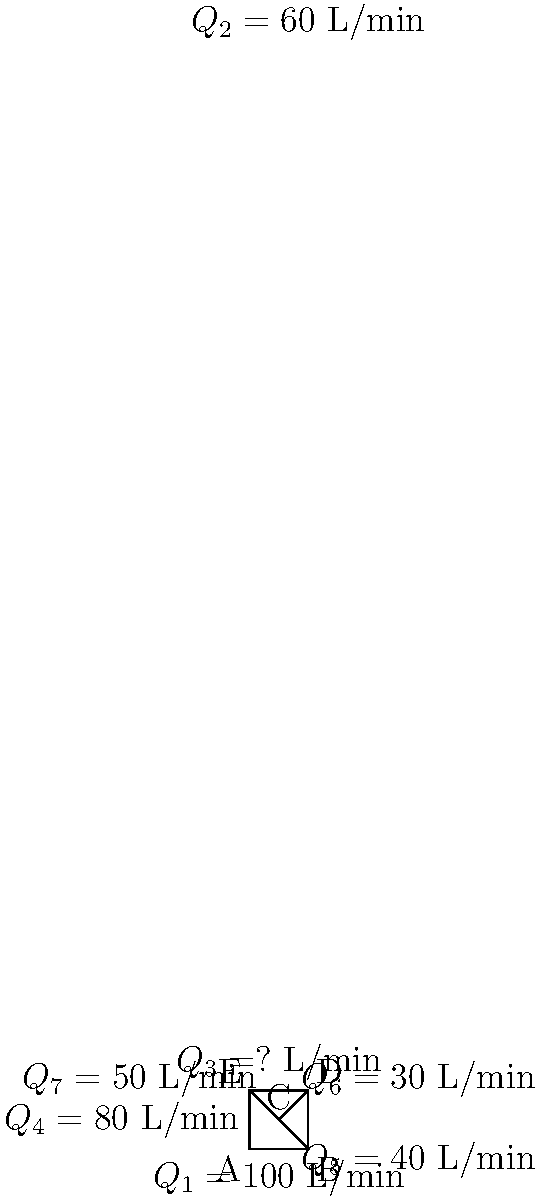In this complex pipe network system, water flows through various interconnected pipes. Given the flow rates for pipes $Q_1$, $Q_2$, $Q_4$, $Q_5$, $Q_6$, and $Q_7$ as shown in the diagram, determine the flow rate $Q_3$ in the pipe connecting points D and E. How might this analysis of flow rates in a pipe network system be metaphorically applied to the creative process in writing, particularly in terms of balancing different narrative elements? To solve this problem, we'll use the principle of conservation of mass, which in fluid mechanics translates to the continuity equation. This principle states that the sum of all inflows must equal the sum of all outflows at any junction in the system.

Step 1: Analyze junction C
Inflow at C = Outflow at C
$Q_5 + Q_6 + Q_7 = 40 + 30 + 50 = 120$ L/min

Step 2: Analyze junction B
Inflow at B = Outflow at B
$Q_1 + Q_5 = 100 + 40 = 140$ L/min
$Q_2 + Q_5 = 60 + 40 = 100$ L/min (outflow)

Step 3: Analyze junction D
Inflow at D = Outflow at D
$Q_2 + Q_6 = 60 + 30 = 90$ L/min (inflow)
$Q_3 + Q_6 = Q_3 + 30$ L/min (outflow)

Step 4: Analyze junction E
Inflow at E = Outflow at E
$Q_3 + Q_7 = Q_3 + 50$ L/min (inflow)
$Q_4 = 80$ L/min (outflow)

Step 5: Solve for $Q_3$
$Q_3 + 50 = 80$
$Q_3 = 30$ L/min

This analysis can be metaphorically applied to the creative writing process. Just as water flows through a network of pipes, ideas and narrative elements flow through the structure of a story. The balance of these elements (character development, plot progression, thematic exploration) must be carefully managed, much like maintaining the correct flow rates in a pipe system. Overemphasis on one element (high flow in one pipe) might lead to underdevelopment in another (low flow elsewhere). The writer, like a hydraulic engineer, must ensure that all components of the story receive the right amount of attention to create a balanced and engaging narrative flow.
Answer: $Q_3 = 30$ L/min 